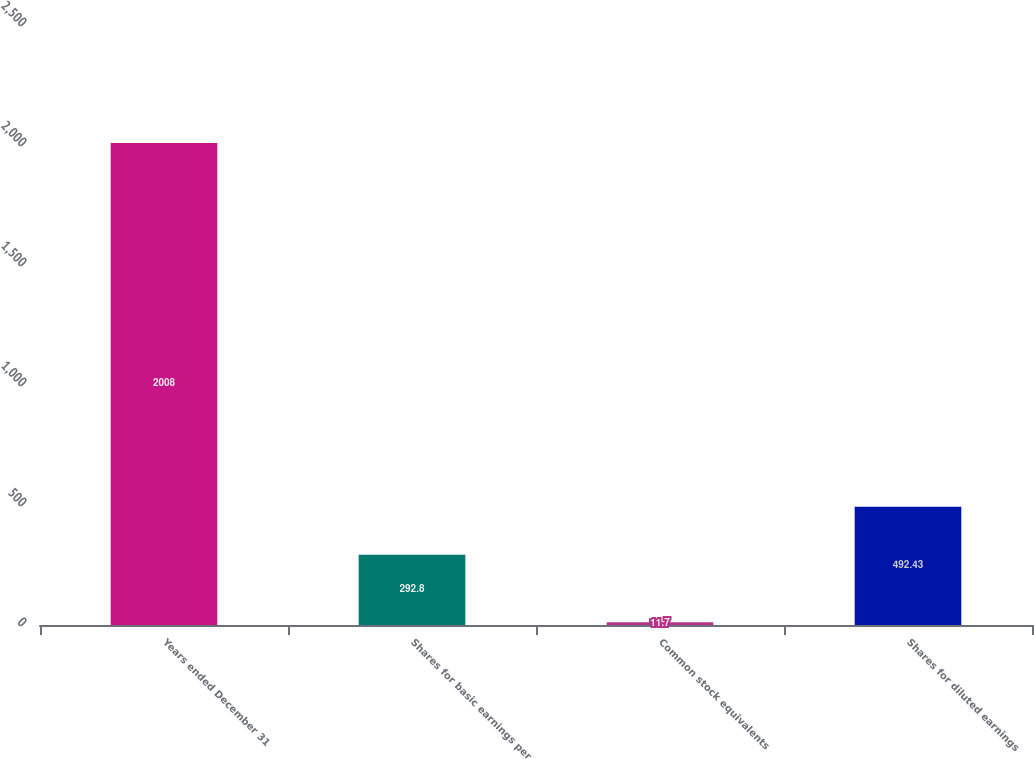<chart> <loc_0><loc_0><loc_500><loc_500><bar_chart><fcel>Years ended December 31<fcel>Shares for basic earnings per<fcel>Common stock equivalents<fcel>Shares for diluted earnings<nl><fcel>2008<fcel>292.8<fcel>11.7<fcel>492.43<nl></chart> 